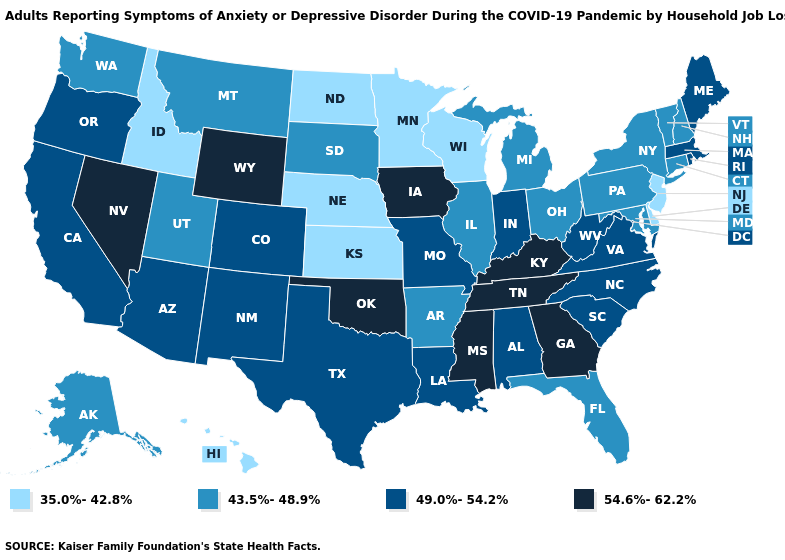Which states hav the highest value in the MidWest?
Quick response, please. Iowa. Among the states that border Wisconsin , which have the lowest value?
Short answer required. Minnesota. Name the states that have a value in the range 35.0%-42.8%?
Short answer required. Delaware, Hawaii, Idaho, Kansas, Minnesota, Nebraska, New Jersey, North Dakota, Wisconsin. What is the highest value in states that border Wyoming?
Keep it brief. 49.0%-54.2%. Name the states that have a value in the range 49.0%-54.2%?
Answer briefly. Alabama, Arizona, California, Colorado, Indiana, Louisiana, Maine, Massachusetts, Missouri, New Mexico, North Carolina, Oregon, Rhode Island, South Carolina, Texas, Virginia, West Virginia. What is the value of Arizona?
Concise answer only. 49.0%-54.2%. Name the states that have a value in the range 54.6%-62.2%?
Write a very short answer. Georgia, Iowa, Kentucky, Mississippi, Nevada, Oklahoma, Tennessee, Wyoming. Which states have the lowest value in the USA?
Short answer required. Delaware, Hawaii, Idaho, Kansas, Minnesota, Nebraska, New Jersey, North Dakota, Wisconsin. What is the value of Massachusetts?
Concise answer only. 49.0%-54.2%. What is the value of Rhode Island?
Keep it brief. 49.0%-54.2%. Name the states that have a value in the range 54.6%-62.2%?
Write a very short answer. Georgia, Iowa, Kentucky, Mississippi, Nevada, Oklahoma, Tennessee, Wyoming. Among the states that border Tennessee , which have the lowest value?
Quick response, please. Arkansas. Which states hav the highest value in the West?
Short answer required. Nevada, Wyoming. What is the value of West Virginia?
Give a very brief answer. 49.0%-54.2%. Among the states that border Louisiana , does Mississippi have the highest value?
Give a very brief answer. Yes. 